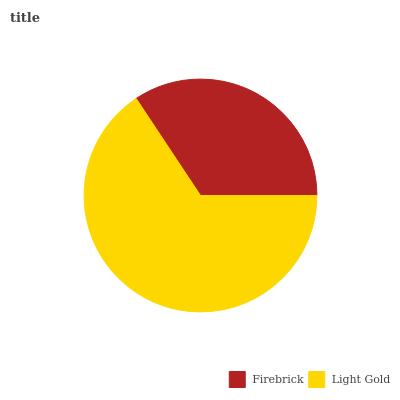Is Firebrick the minimum?
Answer yes or no. Yes. Is Light Gold the maximum?
Answer yes or no. Yes. Is Light Gold the minimum?
Answer yes or no. No. Is Light Gold greater than Firebrick?
Answer yes or no. Yes. Is Firebrick less than Light Gold?
Answer yes or no. Yes. Is Firebrick greater than Light Gold?
Answer yes or no. No. Is Light Gold less than Firebrick?
Answer yes or no. No. Is Light Gold the high median?
Answer yes or no. Yes. Is Firebrick the low median?
Answer yes or no. Yes. Is Firebrick the high median?
Answer yes or no. No. Is Light Gold the low median?
Answer yes or no. No. 